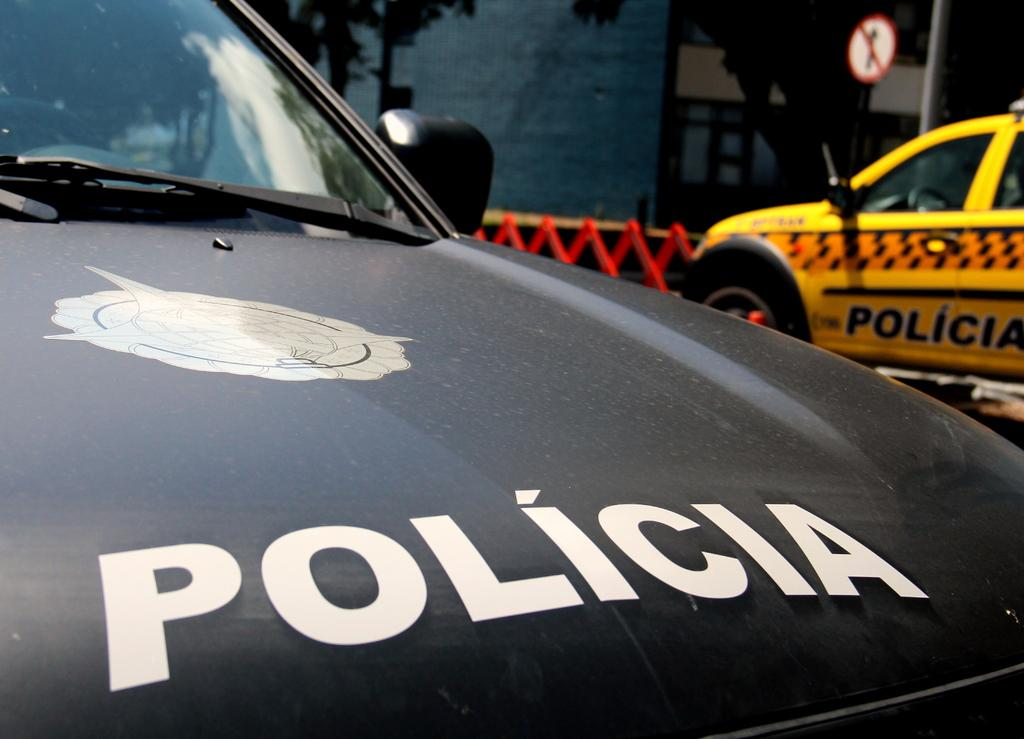<image>
Render a clear and concise summary of the photo. Two policia cars sitting in the street alone 